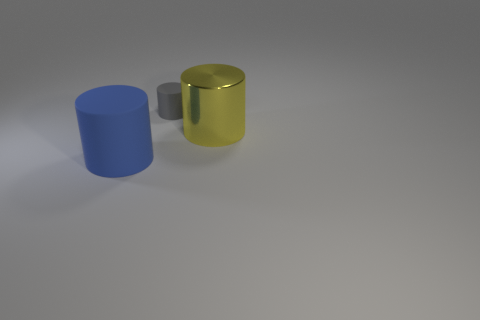Add 1 large metal cylinders. How many objects exist? 4 Subtract all blue shiny balls. Subtract all tiny gray rubber things. How many objects are left? 2 Add 2 matte cylinders. How many matte cylinders are left? 4 Add 1 large cyan shiny cubes. How many large cyan shiny cubes exist? 1 Subtract 0 brown balls. How many objects are left? 3 